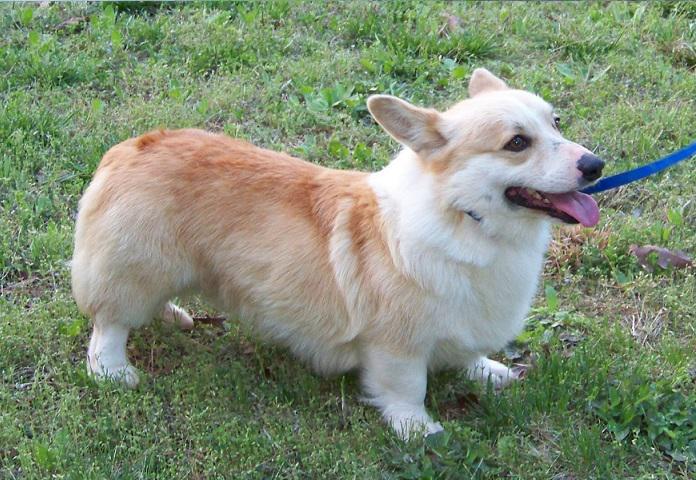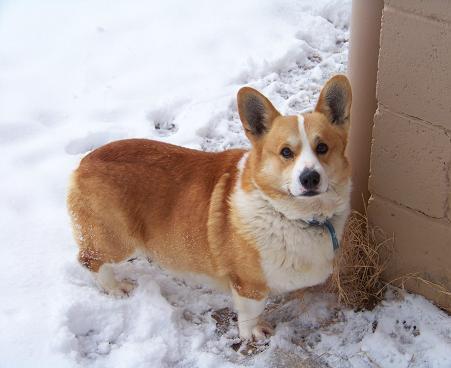The first image is the image on the left, the second image is the image on the right. Assess this claim about the two images: "There are at most two corgis.". Correct or not? Answer yes or no. Yes. 